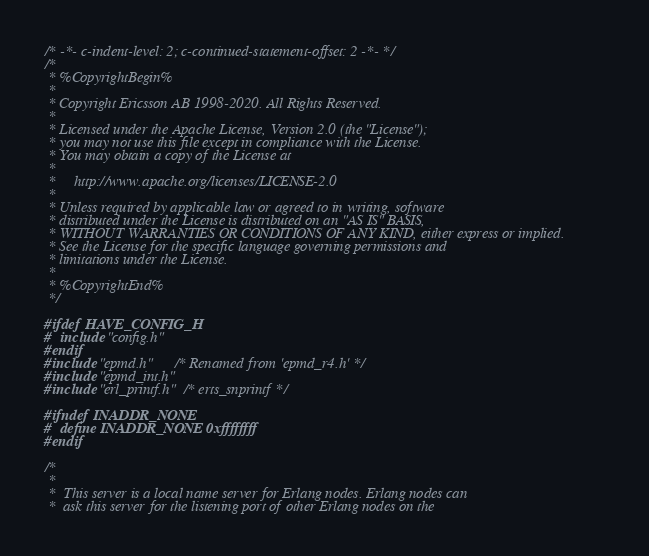<code> <loc_0><loc_0><loc_500><loc_500><_C_>/* -*- c-indent-level: 2; c-continued-statement-offset: 2 -*- */ 
/*
 * %CopyrightBegin%
 *
 * Copyright Ericsson AB 1998-2020. All Rights Reserved.
 *
 * Licensed under the Apache License, Version 2.0 (the "License");
 * you may not use this file except in compliance with the License.
 * You may obtain a copy of the License at
 *
 *     http://www.apache.org/licenses/LICENSE-2.0
 *
 * Unless required by applicable law or agreed to in writing, software
 * distributed under the License is distributed on an "AS IS" BASIS,
 * WITHOUT WARRANTIES OR CONDITIONS OF ANY KIND, either express or implied.
 * See the License for the specific language governing permissions and
 * limitations under the License.
 *
 * %CopyrightEnd%
 */

#ifdef HAVE_CONFIG_H
#  include "config.h"
#endif
#include "epmd.h"     /* Renamed from 'epmd_r4.h' */
#include "epmd_int.h"
#include "erl_printf.h" /* erts_snprintf */

#ifndef INADDR_NONE
#  define INADDR_NONE 0xffffffff
#endif

/*
 *  
 *  This server is a local name server for Erlang nodes. Erlang nodes can
 *  ask this server for the listening port of other Erlang nodes on the</code> 